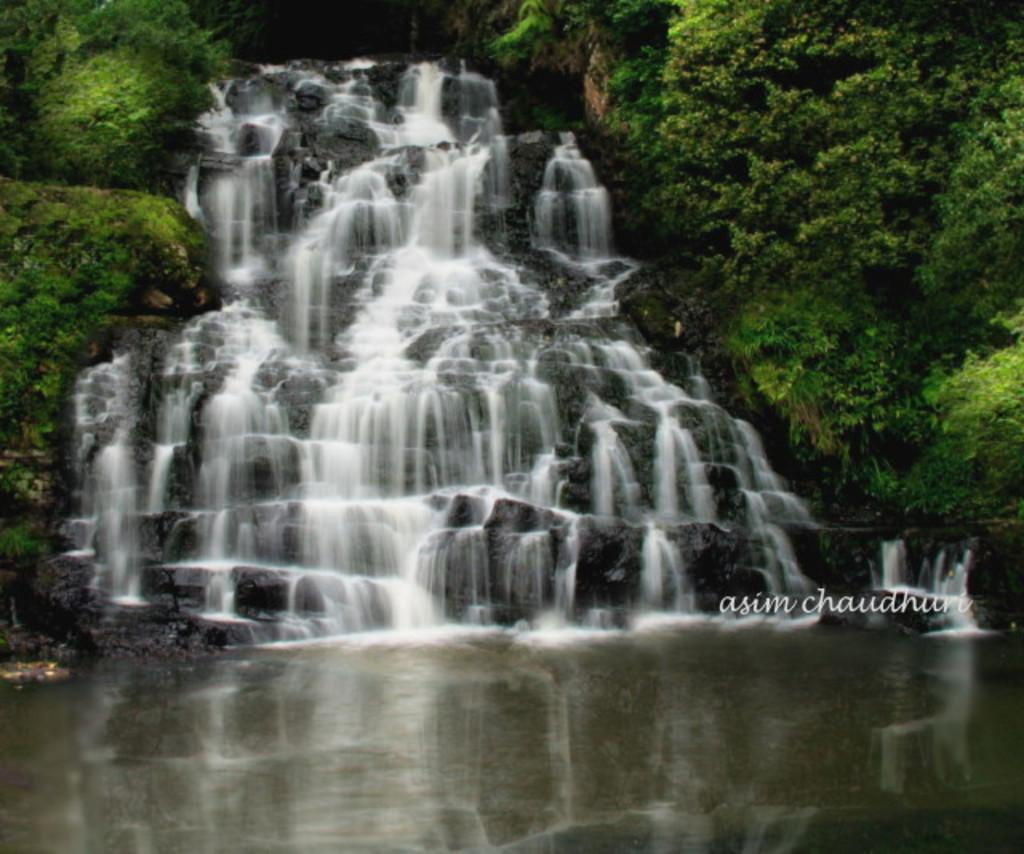What is present in the front of the image? There is water in the front of the image. What can be seen in the background of the image? There is a water fountain and trees in the background of the image. What type of joke is being told near the water fountain in the image? There is no indication of a joke or anyone telling a joke in the image. Is there a tent visible in the image? No, there is no tent present in the image. 